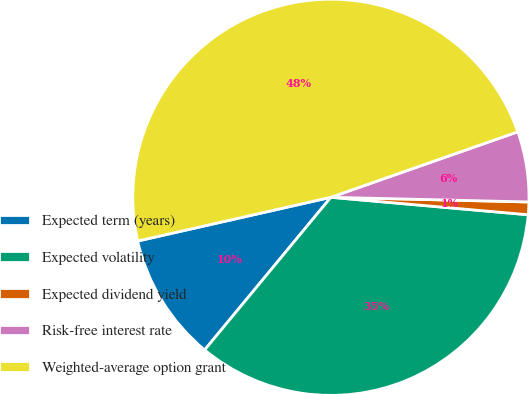Convert chart to OTSL. <chart><loc_0><loc_0><loc_500><loc_500><pie_chart><fcel>Expected term (years)<fcel>Expected volatility<fcel>Expected dividend yield<fcel>Risk-free interest rate<fcel>Weighted-average option grant<nl><fcel>10.46%<fcel>34.59%<fcel>1.03%<fcel>5.74%<fcel>48.18%<nl></chart> 